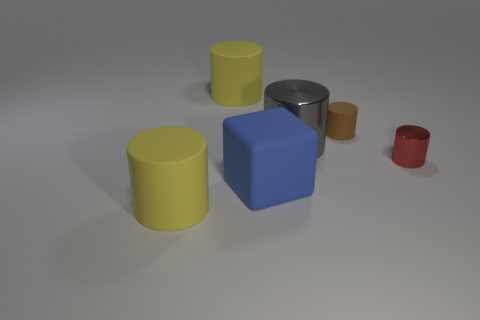How does the lighting affect the appearance of the objects? The lighting in the image appears to be diffused, possibly from an overhead source, creating soft shadows that gently outline the objects on the ground. This diffused lighting helps to bring out the textures and colors of the objects, while also creating a sense of depth and three-dimensionality. The way the light highlights the edges and curves of the objects emphasizes their geometrical properties and can give us clues about the materials they are made of, as some surfaces reflect more light than others. 